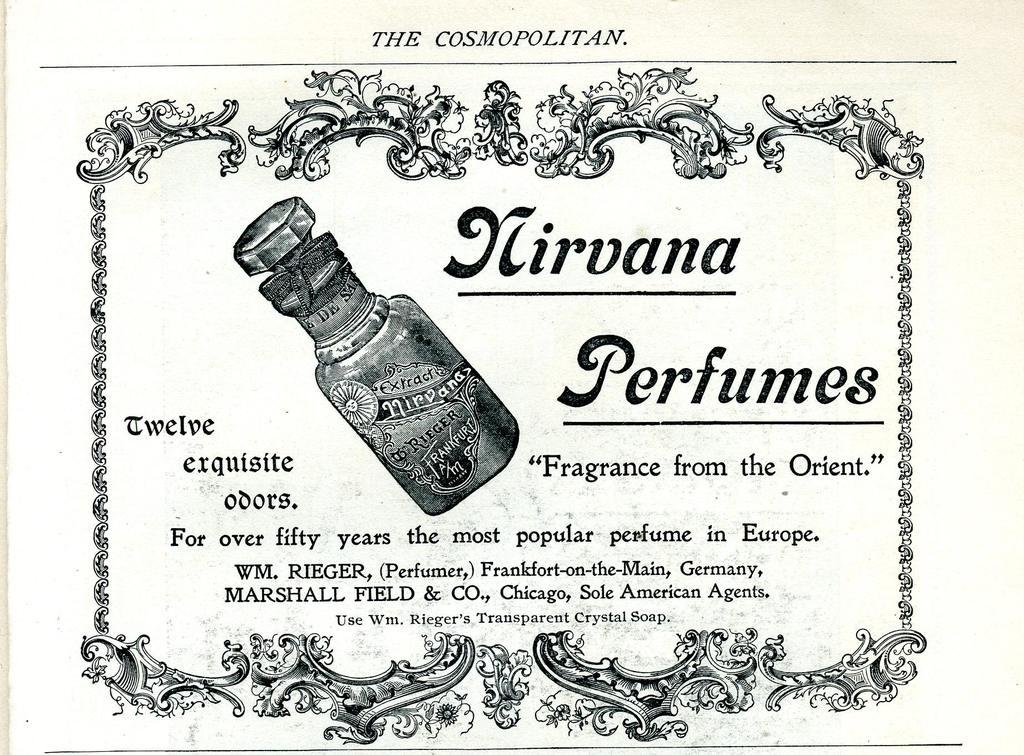<image>
Provide a brief description of the given image. A vintage black and white advertisement for Nirvana Perfumes 